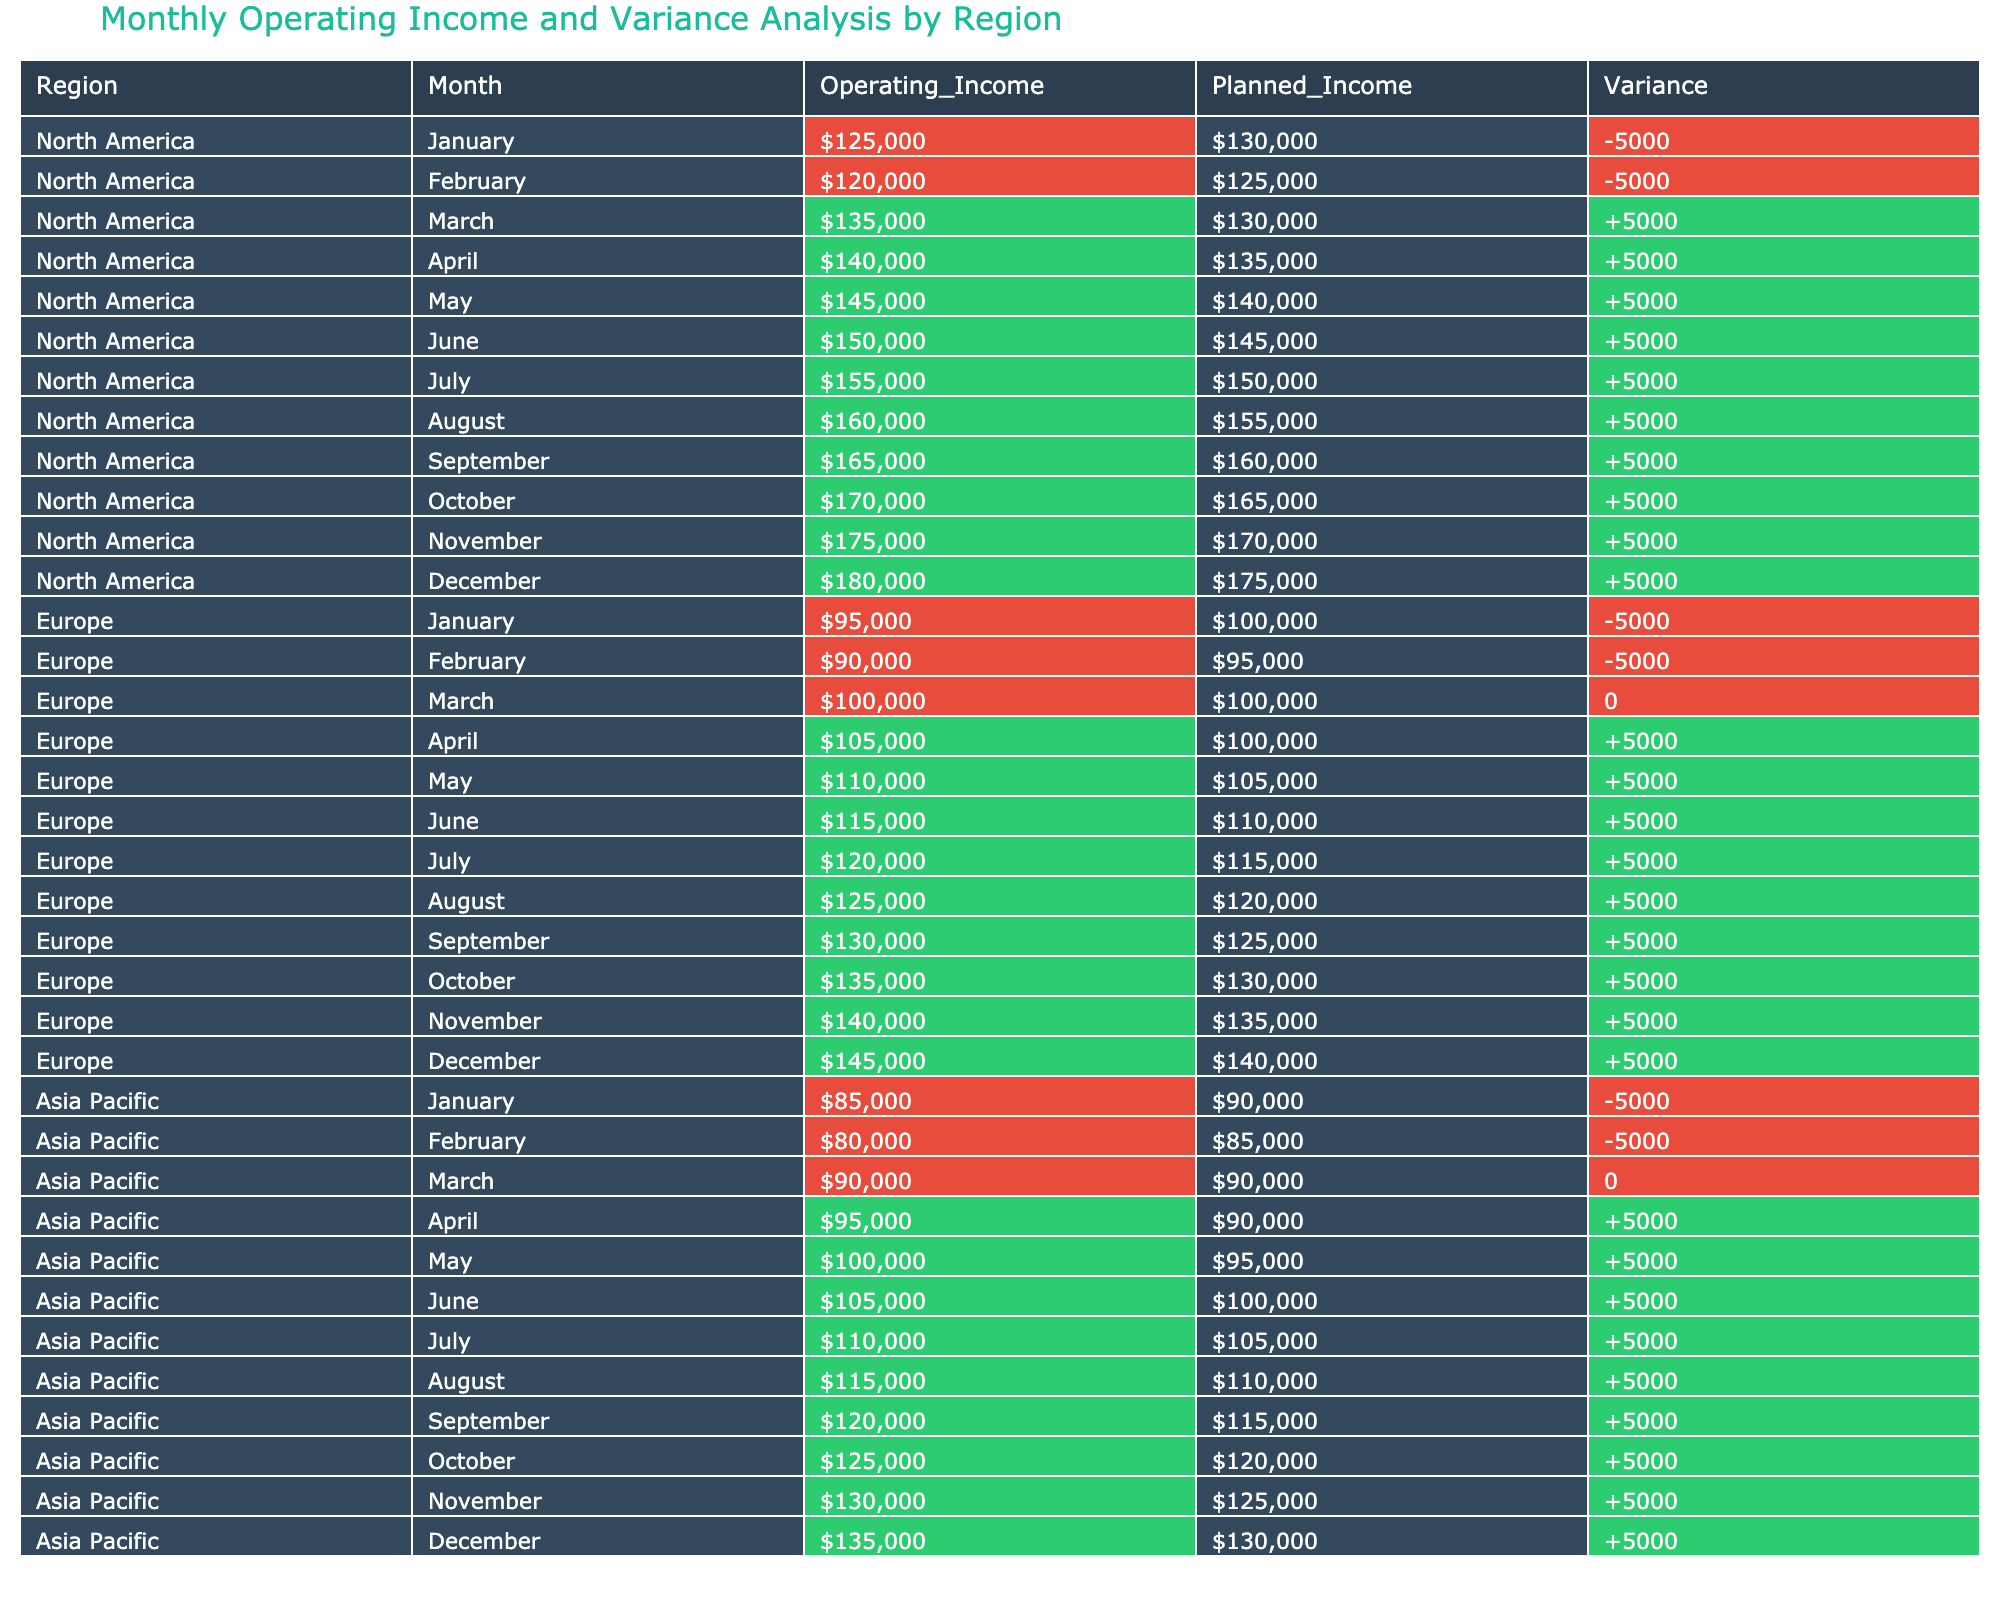What is the Operating Income for North America in March? The table shows that in March for North America, the Operating Income is listed as $135,000.
Answer: $135,000 What was the variance for Europe in April? Looking at the table, the variance for April in Europe is shown as +$5,000.
Answer: +$5,000 What is the total Operating Income for Asia Pacific from January to June? To find the total Operating Income from January to June for Asia Pacific, we sum the monthly values: 85,000 + 80,000 + 90,000 + 95,000 + 100,000 + 105,000 = 555,000.
Answer: 555,000 Is the Operating Income always greater than Planned Income for North America from March to December? Examining the values from March to December for North America, the Operating Income is consistently higher than the Planned Income, indicating the statement is true.
Answer: Yes Which region had the highest Operating Income in December? By checking the December line for all regions, North America has an Operating Income of $180,000, which is greater than Europe’s $145,000 and Asia Pacific’s $135,000. Thus, North America had the highest.
Answer: North America What is the average Planned Income for Europe over the 12 months? To find the average Planned Income for Europe, we sum the Planned Income values for all months (100,000 + 95,000 + 100,000 + 100,000 + 105,000 + 110,000 + 115,000 + 120,000 + 125,000 + 130,000 + 135,000 + 140,000 = 1,485,000) and divide by 12, which equals 123,750.
Answer: 123,750 Was there any month where Asia Pacific's Operating Income met the Planned Income? Checking the table for Asia Pacific, in March, the Operating Income of $90,000 exactly equals the Planned Income of $90,000, so there is at least one month where they met.
Answer: Yes What is the total variance across all months for North America? To find the total variance for North America, we sum the variations: -5000 + -5000 + 5000 + 5000 + 5000 + 5000 + 5000 + 5000 + 5000 + 5000 + 5000 + 5000 = 5000 - 10000 + 60000 = 5000, giving a total variance of +60,000 at the end.
Answer: +60,000 